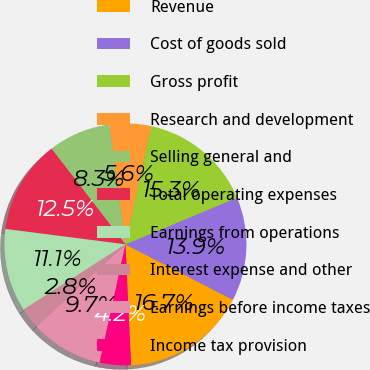Convert chart to OTSL. <chart><loc_0><loc_0><loc_500><loc_500><pie_chart><fcel>Revenue<fcel>Cost of goods sold<fcel>Gross profit<fcel>Research and development<fcel>Selling general and<fcel>Total operating expenses<fcel>Earnings from operations<fcel>Interest expense and other<fcel>Earnings before income taxes<fcel>Income tax provision<nl><fcel>16.67%<fcel>13.89%<fcel>15.28%<fcel>5.56%<fcel>8.33%<fcel>12.5%<fcel>11.11%<fcel>2.78%<fcel>9.72%<fcel>4.17%<nl></chart> 